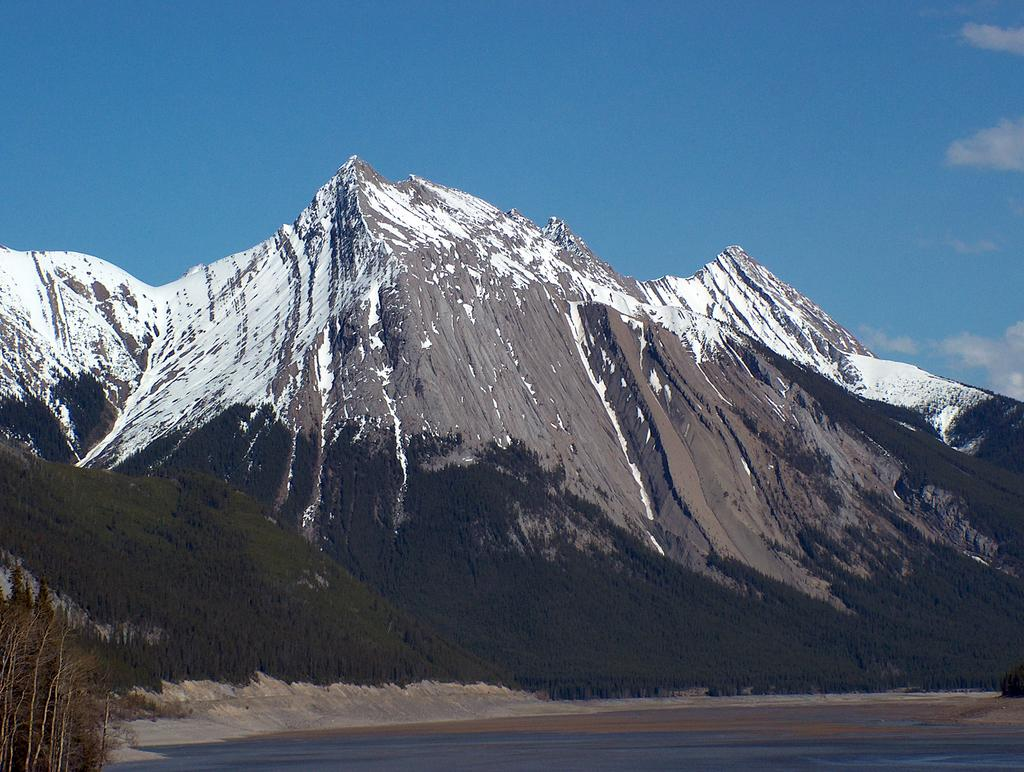What is the terrain like in the image? The mountains in the image are covered with snow. What can be seen in the background of the image? The sky is visible in the background of the image. What is the condition of the sky in the image? Clouds are present in the sky. Where are the cherries growing in the image? There are no cherries present in the image. What letter is visible on the mountains in the image? There are no letters visible on the mountains in the image. 